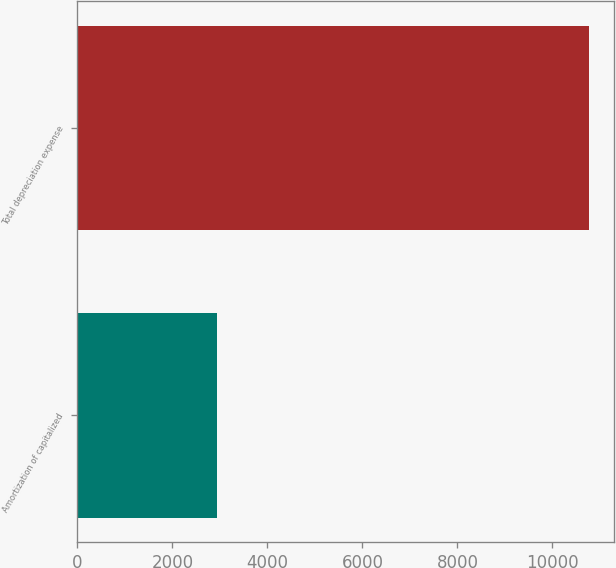<chart> <loc_0><loc_0><loc_500><loc_500><bar_chart><fcel>Amortization of capitalized<fcel>Total depreciation expense<nl><fcel>2938<fcel>10763<nl></chart> 